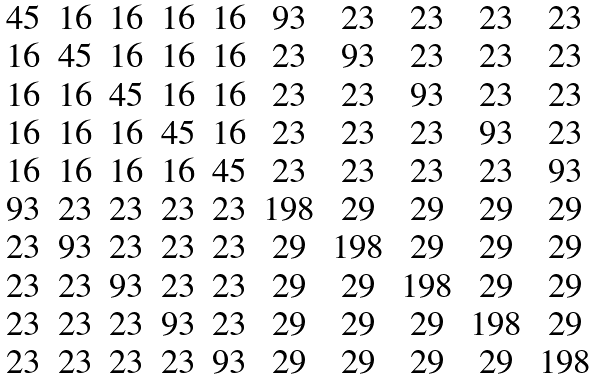Convert formula to latex. <formula><loc_0><loc_0><loc_500><loc_500>\begin{matrix} 4 5 & 1 6 & 1 6 & 1 6 & 1 6 & 9 3 & 2 3 & 2 3 & 2 3 & 2 3 \\ 1 6 & 4 5 & 1 6 & 1 6 & 1 6 & 2 3 & 9 3 & 2 3 & 2 3 & 2 3 \\ 1 6 & 1 6 & 4 5 & 1 6 & 1 6 & 2 3 & 2 3 & 9 3 & 2 3 & 2 3 \\ 1 6 & 1 6 & 1 6 & 4 5 & 1 6 & 2 3 & 2 3 & 2 3 & 9 3 & 2 3 \\ 1 6 & 1 6 & 1 6 & 1 6 & 4 5 & 2 3 & 2 3 & 2 3 & 2 3 & 9 3 \\ 9 3 & 2 3 & 2 3 & 2 3 & 2 3 & 1 9 8 & 2 9 & 2 9 & 2 9 & 2 9 \\ 2 3 & 9 3 & 2 3 & 2 3 & 2 3 & 2 9 & 1 9 8 & 2 9 & 2 9 & 2 9 \\ 2 3 & 2 3 & 9 3 & 2 3 & 2 3 & 2 9 & 2 9 & 1 9 8 & 2 9 & 2 9 \\ 2 3 & 2 3 & 2 3 & 9 3 & 2 3 & 2 9 & 2 9 & 2 9 & 1 9 8 & 2 9 \\ 2 3 & 2 3 & 2 3 & 2 3 & 9 3 & 2 9 & 2 9 & 2 9 & 2 9 & 1 9 8 \\ \end{matrix}</formula> 